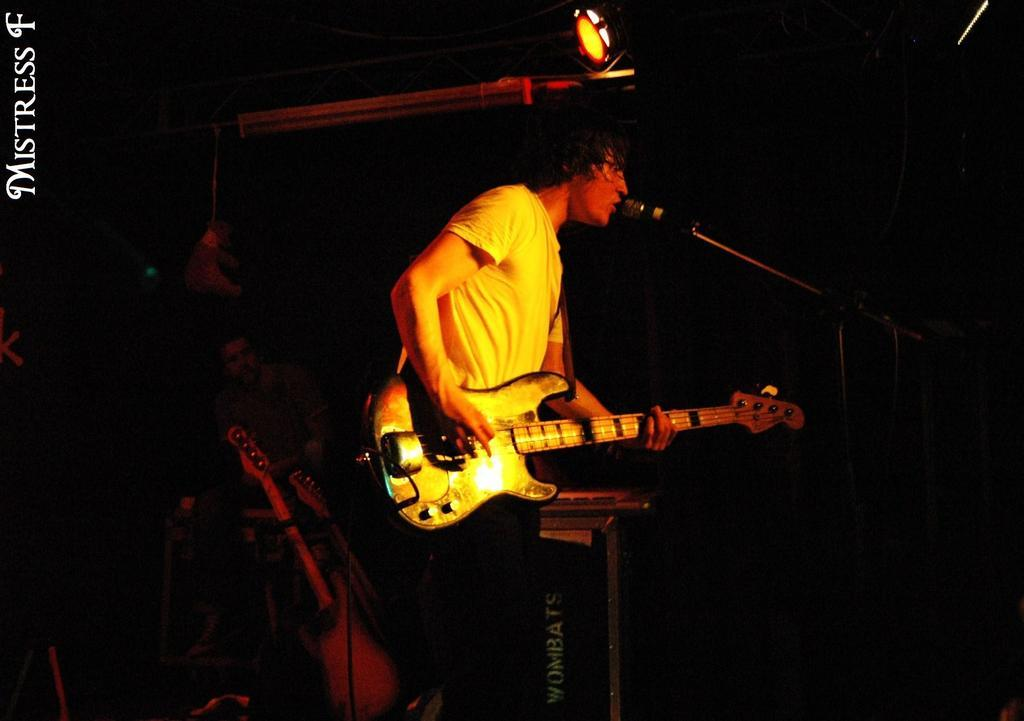What is the main subject of the image? The main subject of the image is a boy. What is the boy wearing? The boy is wearing a white t-shirt. What activity is the boy engaged in? The boy is playing the guitar and singing into a microphone. Are there any other people in the image? Yes, there is another boy in the image. What is the second boy doing? The second boy is sitting on a chair and playing the guitar. Can you see any rabbits in the image? No, there are no rabbits present in the image. What type of structure is the boy sitting on while playing the guitar? The boy is not sitting on a structure; he is sitting on a chair. 